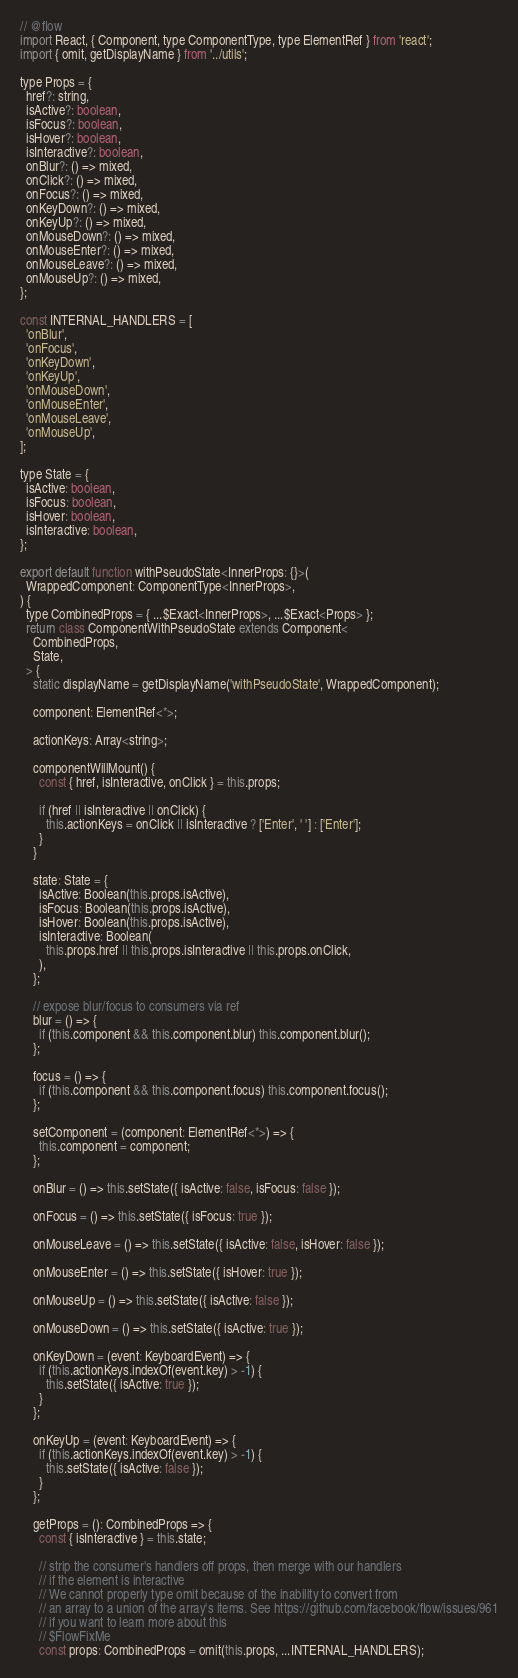<code> <loc_0><loc_0><loc_500><loc_500><_JavaScript_>// @flow
import React, { Component, type ComponentType, type ElementRef } from 'react';
import { omit, getDisplayName } from '../utils';

type Props = {
  href?: string,
  isActive?: boolean,
  isFocus?: boolean,
  isHover?: boolean,
  isInteractive?: boolean,
  onBlur?: () => mixed,
  onClick?: () => mixed,
  onFocus?: () => mixed,
  onKeyDown?: () => mixed,
  onKeyUp?: () => mixed,
  onMouseDown?: () => mixed,
  onMouseEnter?: () => mixed,
  onMouseLeave?: () => mixed,
  onMouseUp?: () => mixed,
};

const INTERNAL_HANDLERS = [
  'onBlur',
  'onFocus',
  'onKeyDown',
  'onKeyUp',
  'onMouseDown',
  'onMouseEnter',
  'onMouseLeave',
  'onMouseUp',
];

type State = {
  isActive: boolean,
  isFocus: boolean,
  isHover: boolean,
  isInteractive: boolean,
};

export default function withPseudoState<InnerProps: {}>(
  WrappedComponent: ComponentType<InnerProps>,
) {
  type CombinedProps = { ...$Exact<InnerProps>, ...$Exact<Props> };
  return class ComponentWithPseudoState extends Component<
    CombinedProps,
    State,
  > {
    static displayName = getDisplayName('withPseudoState', WrappedComponent);

    component: ElementRef<*>;

    actionKeys: Array<string>;

    componentWillMount() {
      const { href, isInteractive, onClick } = this.props;

      if (href || isInteractive || onClick) {
        this.actionKeys = onClick || isInteractive ? ['Enter', ' '] : ['Enter'];
      }
    }

    state: State = {
      isActive: Boolean(this.props.isActive),
      isFocus: Boolean(this.props.isActive),
      isHover: Boolean(this.props.isActive),
      isInteractive: Boolean(
        this.props.href || this.props.isInteractive || this.props.onClick,
      ),
    };

    // expose blur/focus to consumers via ref
    blur = () => {
      if (this.component && this.component.blur) this.component.blur();
    };

    focus = () => {
      if (this.component && this.component.focus) this.component.focus();
    };

    setComponent = (component: ElementRef<*>) => {
      this.component = component;
    };

    onBlur = () => this.setState({ isActive: false, isFocus: false });

    onFocus = () => this.setState({ isFocus: true });

    onMouseLeave = () => this.setState({ isActive: false, isHover: false });

    onMouseEnter = () => this.setState({ isHover: true });

    onMouseUp = () => this.setState({ isActive: false });

    onMouseDown = () => this.setState({ isActive: true });

    onKeyDown = (event: KeyboardEvent) => {
      if (this.actionKeys.indexOf(event.key) > -1) {
        this.setState({ isActive: true });
      }
    };

    onKeyUp = (event: KeyboardEvent) => {
      if (this.actionKeys.indexOf(event.key) > -1) {
        this.setState({ isActive: false });
      }
    };

    getProps = (): CombinedProps => {
      const { isInteractive } = this.state;

      // strip the consumer's handlers off props, then merge with our handlers
      // if the element is interactive
      // We cannot properly type omit because of the inability to convert from
      // an array to a union of the array's items. See https://github.com/facebook/flow/issues/961
      // if you want to learn more about this
      // $FlowFixMe
      const props: CombinedProps = omit(this.props, ...INTERNAL_HANDLERS);
</code> 